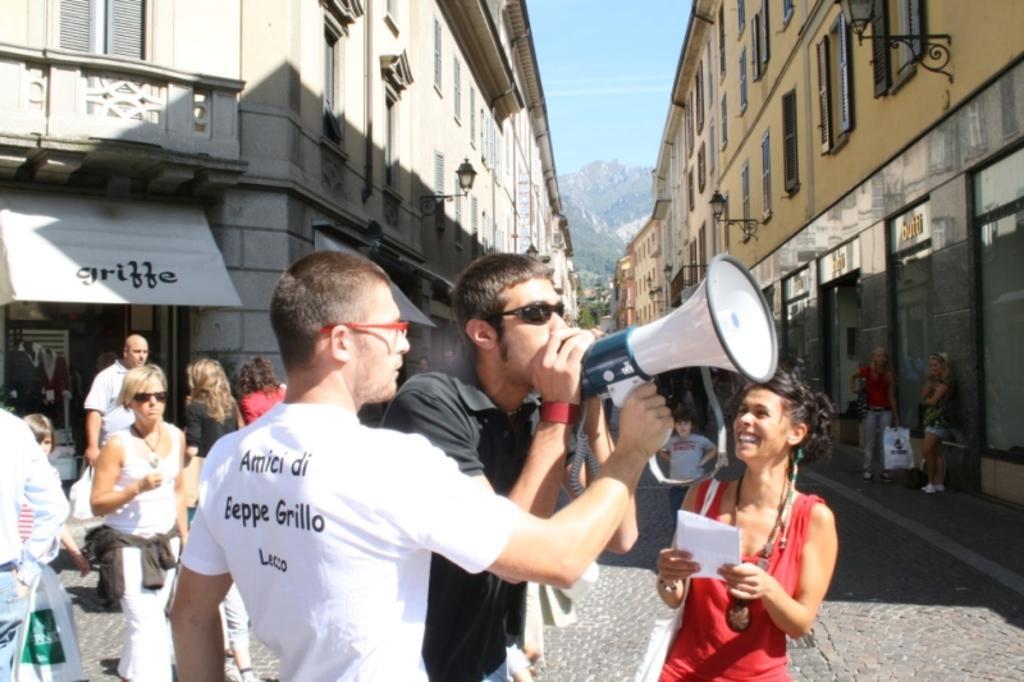Please provide a concise description of this image. In this image, we can see a group of people are standing. Here a person is holding some object. Right side of the image, we can see a woman is holding a person and smiling. At the bottom, we can see the walkway. Background we can see few buildings, store, lights, walls, windows, railing and trees. Background of the image, we can see hill and sky. 